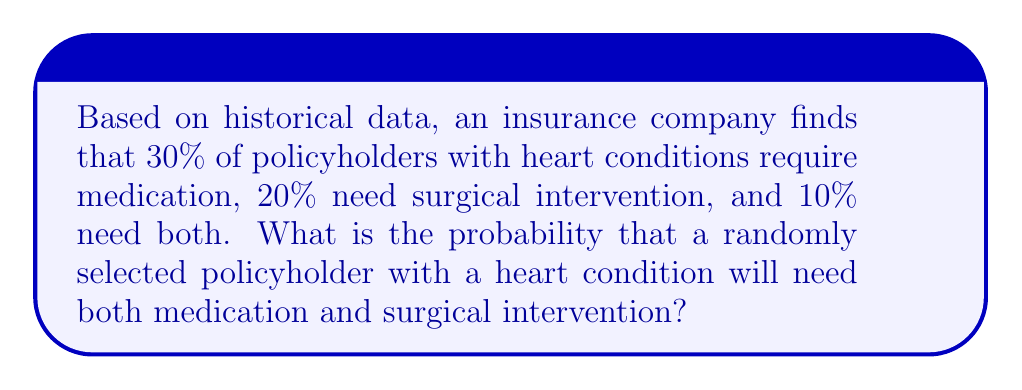Teach me how to tackle this problem. Let's approach this step-by-step:

1) Let's define our events:
   M: Policyholder needs medication
   S: Policyholder needs surgical intervention

2) We're given the following probabilities:
   $P(M) = 0.30$ (30% need medication)
   $P(S) = 0.20$ (20% need surgical intervention)
   $P(M \cap S) = 0.10$ (10% need both)

3) The question is asking for $P(M \cap S)$, which we're directly given as 0.10 or 10%.

4) To verify this, we can use the addition rule of probability:
   $P(M \cup S) = P(M) + P(S) - P(M \cap S)$

   Substituting the values:
   $P(M \cup S) = 0.30 + 0.20 - 0.10 = 0.40$

   This means 40% of policyholders need either medication or surgery or both, which is consistent with the given information.

5) Therefore, the probability that a randomly selected policyholder with a heart condition will need both medication and surgical intervention is 0.10 or 10%.
Answer: $0.10$ or $10\%$ 